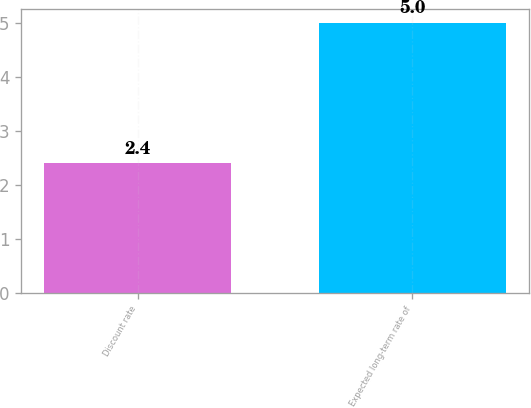<chart> <loc_0><loc_0><loc_500><loc_500><bar_chart><fcel>Discount rate<fcel>Expected long-term rate of<nl><fcel>2.4<fcel>5<nl></chart> 